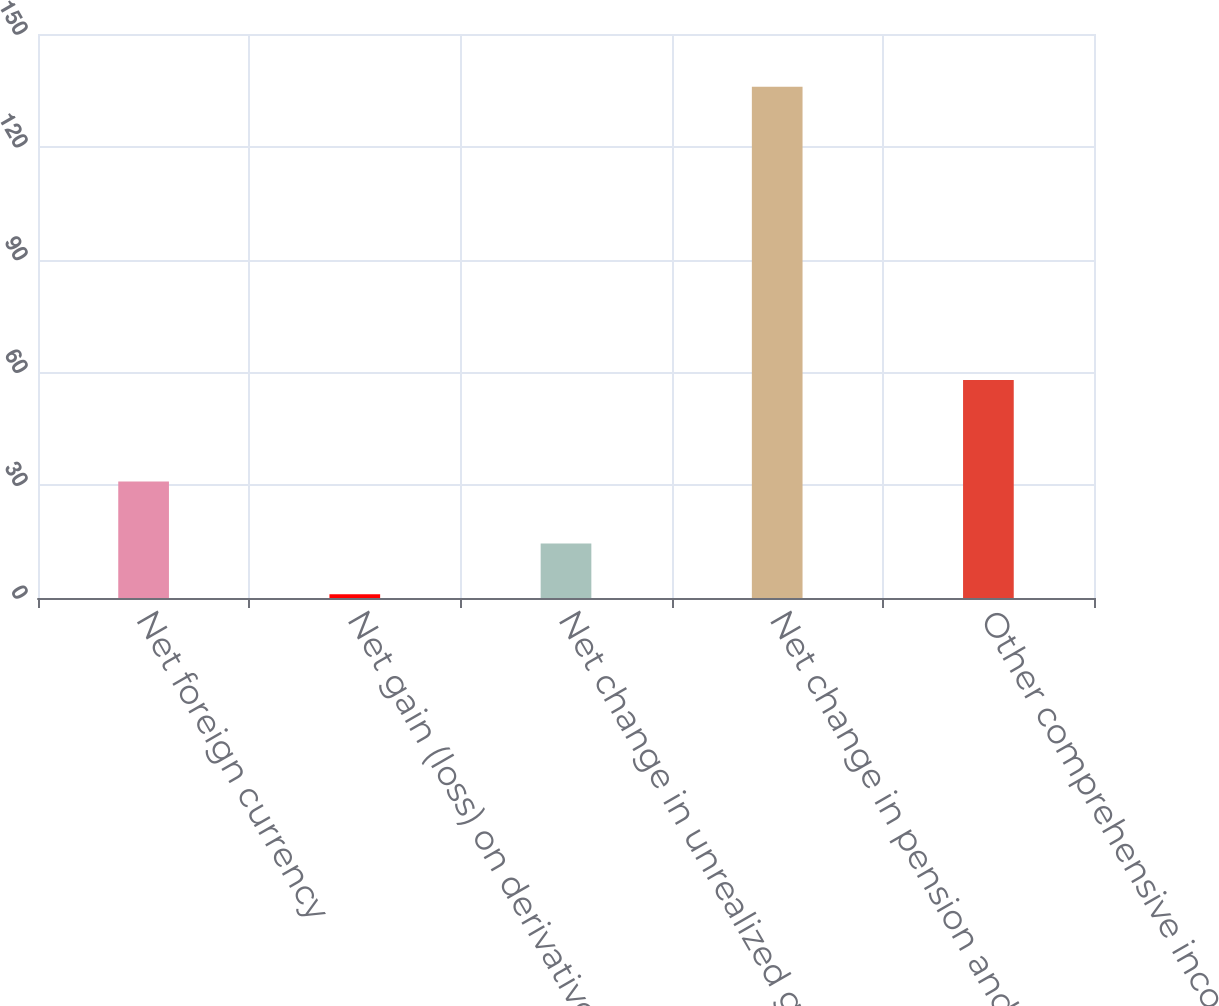Convert chart to OTSL. <chart><loc_0><loc_0><loc_500><loc_500><bar_chart><fcel>Net foreign currency<fcel>Net gain (loss) on derivatives<fcel>Net change in unrealized gain<fcel>Net change in pension and<fcel>Other comprehensive income<nl><fcel>31<fcel>1<fcel>14.5<fcel>136<fcel>58<nl></chart> 